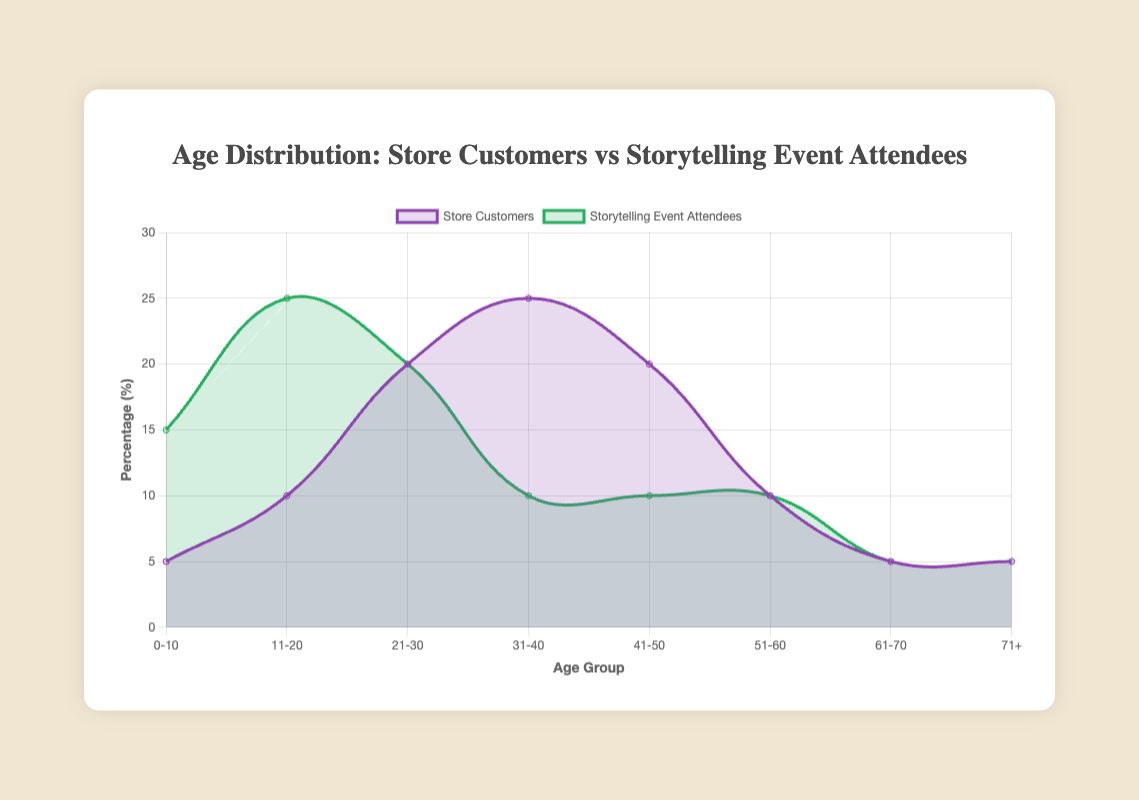Which age group has the highest percentage among store customers? The age group 31-40 has the highest percentage of store customers. By looking at the height of the purple curve, it reaches its peak at 25% for the 31-40 age group.
Answer: 31-40 Which age group has the highest percentage among storytelling event attendees? The age group 11-20 has the highest percentage of attendees. The green curve shows a peak at 25% for the 11-20 age group.
Answer: 11-20 What is the percentage difference between 0-10 age group store customers and storytelling event attendees? The percentage for store customers in the 0-10 age group is 5%, and for event attendees, it is 15%. The difference is 15% - 5% = 10%.
Answer: 10% Which age group has the steepest rise in the percentage for storytelling event attendees compared to store customers? Comparing the differences between the curves, the 0-10 age group has a steep rise for attendees compared to store customers. Store customers are at 5%, while attendees are at 15%, showing a significant increase.
Answer: 0-10 In which age group are store customers and event attendees percentages equal? For both the 61-70 and 71+ age groups, the percentages are equal at 5%. The two lines overlap in these age ranges.
Answer: 61-70 and 71+ What is the average percentage of store customers for the age groups 31-40 and 41-50? For the age group 31-40, the percentage is 25%. For 41-50, it is 20%. The average is (25% + 20%) / 2 = 22.5%.
Answer: 22.5% Compare the percentages of the 21-30 age group for both store customers and storytelling event attendees. Which is higher? Both store customers and event attendees have the same percentage for the 21-30 age group, which is 20%.
Answer: Equal Which age group shows the largest percentage drop from store customers to storytelling event attendees? The age group 31-40 shows the largest drop. Store customers are at 25%, while event attendees are only at 10%. The drop is 25% - 10% = 15%.
Answer: 31-40 If you combine the percentages of the 51-60 age group for both store customers and storytelling event attendees, what is the total? For 51-60 age group, store customers represent 10% and storytelling event attendees also represent 10%. Therefore, the total is 10% + 10% = 20%.
Answer: 20% 